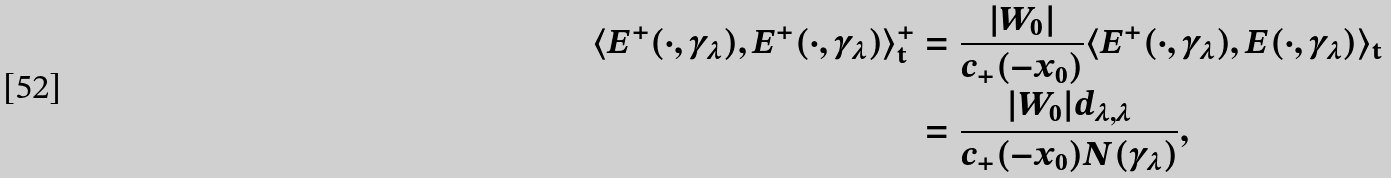<formula> <loc_0><loc_0><loc_500><loc_500>\langle E ^ { + } ( \cdot , \gamma _ { \lambda } ) , E ^ { + } ( \cdot , \gamma _ { \lambda } ) \rangle _ { \mathbf t } ^ { + } & = \frac { | W _ { 0 } | } { c _ { + } ( - x _ { 0 } ) } \langle E ^ { + } ( \cdot , \gamma _ { \lambda } ) , E ( \cdot , \gamma _ { \lambda } ) \rangle _ { \mathbf t } \\ & = \frac { | W _ { 0 } | d _ { \lambda , \lambda } } { c _ { + } ( - x _ { 0 } ) N ( \gamma _ { \lambda } ) } ,</formula> 